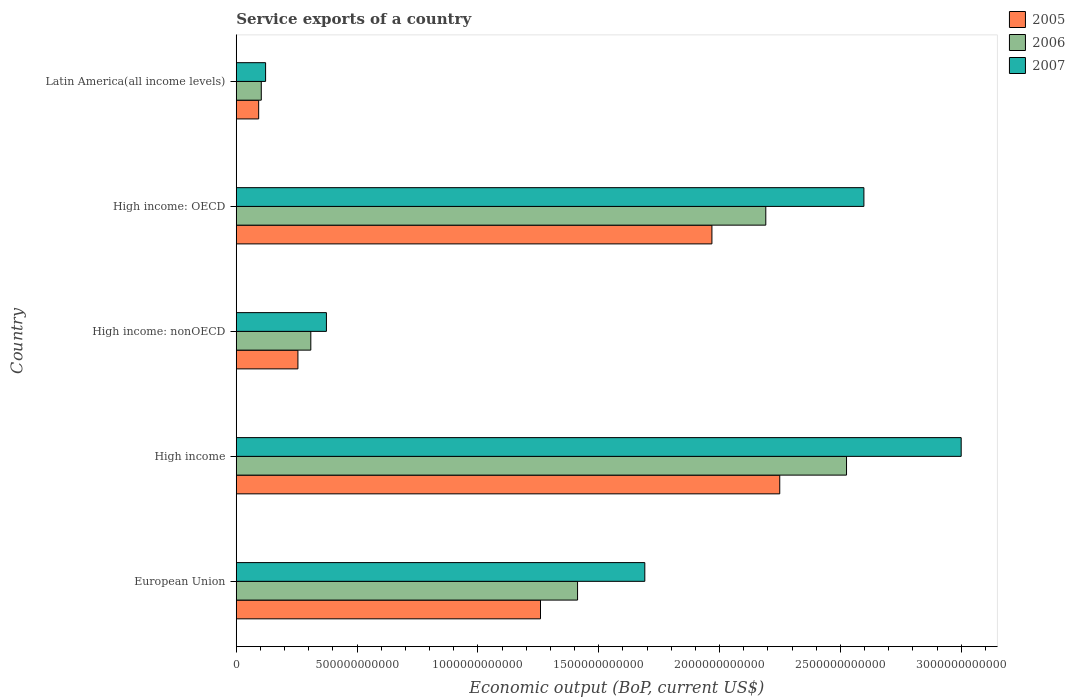How many bars are there on the 1st tick from the bottom?
Offer a very short reply. 3. What is the label of the 1st group of bars from the top?
Your response must be concise. Latin America(all income levels). In how many cases, is the number of bars for a given country not equal to the number of legend labels?
Provide a short and direct response. 0. What is the service exports in 2005 in High income: OECD?
Your answer should be very brief. 1.97e+12. Across all countries, what is the maximum service exports in 2005?
Your answer should be compact. 2.25e+12. Across all countries, what is the minimum service exports in 2006?
Offer a very short reply. 1.04e+11. In which country was the service exports in 2006 maximum?
Your answer should be compact. High income. In which country was the service exports in 2005 minimum?
Offer a terse response. Latin America(all income levels). What is the total service exports in 2006 in the graph?
Provide a short and direct response. 6.54e+12. What is the difference between the service exports in 2007 in High income: OECD and that in High income: nonOECD?
Your answer should be very brief. 2.22e+12. What is the difference between the service exports in 2007 in High income: OECD and the service exports in 2006 in High income?
Keep it short and to the point. 7.19e+1. What is the average service exports in 2005 per country?
Provide a succinct answer. 1.16e+12. What is the difference between the service exports in 2007 and service exports in 2006 in Latin America(all income levels)?
Your answer should be compact. 1.79e+1. In how many countries, is the service exports in 2005 greater than 1800000000000 US$?
Your response must be concise. 2. What is the ratio of the service exports in 2007 in High income: OECD to that in Latin America(all income levels)?
Give a very brief answer. 21.39. Is the difference between the service exports in 2007 in European Union and Latin America(all income levels) greater than the difference between the service exports in 2006 in European Union and Latin America(all income levels)?
Your response must be concise. Yes. What is the difference between the highest and the second highest service exports in 2007?
Provide a succinct answer. 4.03e+11. What is the difference between the highest and the lowest service exports in 2006?
Keep it short and to the point. 2.42e+12. Is it the case that in every country, the sum of the service exports in 2007 and service exports in 2006 is greater than the service exports in 2005?
Offer a terse response. Yes. How many bars are there?
Make the answer very short. 15. Are all the bars in the graph horizontal?
Your response must be concise. Yes. How many countries are there in the graph?
Ensure brevity in your answer.  5. What is the difference between two consecutive major ticks on the X-axis?
Keep it short and to the point. 5.00e+11. Are the values on the major ticks of X-axis written in scientific E-notation?
Offer a terse response. No. Does the graph contain grids?
Your response must be concise. No. How many legend labels are there?
Ensure brevity in your answer.  3. What is the title of the graph?
Make the answer very short. Service exports of a country. What is the label or title of the X-axis?
Offer a terse response. Economic output (BoP, current US$). What is the label or title of the Y-axis?
Offer a terse response. Country. What is the Economic output (BoP, current US$) of 2005 in European Union?
Provide a succinct answer. 1.26e+12. What is the Economic output (BoP, current US$) of 2006 in European Union?
Make the answer very short. 1.41e+12. What is the Economic output (BoP, current US$) in 2007 in European Union?
Make the answer very short. 1.69e+12. What is the Economic output (BoP, current US$) in 2005 in High income?
Provide a short and direct response. 2.25e+12. What is the Economic output (BoP, current US$) in 2006 in High income?
Keep it short and to the point. 2.53e+12. What is the Economic output (BoP, current US$) in 2007 in High income?
Make the answer very short. 3.00e+12. What is the Economic output (BoP, current US$) of 2005 in High income: nonOECD?
Offer a very short reply. 2.55e+11. What is the Economic output (BoP, current US$) of 2006 in High income: nonOECD?
Provide a succinct answer. 3.09e+11. What is the Economic output (BoP, current US$) in 2007 in High income: nonOECD?
Make the answer very short. 3.73e+11. What is the Economic output (BoP, current US$) of 2005 in High income: OECD?
Provide a succinct answer. 1.97e+12. What is the Economic output (BoP, current US$) of 2006 in High income: OECD?
Provide a succinct answer. 2.19e+12. What is the Economic output (BoP, current US$) in 2007 in High income: OECD?
Provide a succinct answer. 2.60e+12. What is the Economic output (BoP, current US$) of 2005 in Latin America(all income levels)?
Offer a terse response. 9.28e+1. What is the Economic output (BoP, current US$) in 2006 in Latin America(all income levels)?
Your answer should be very brief. 1.04e+11. What is the Economic output (BoP, current US$) in 2007 in Latin America(all income levels)?
Make the answer very short. 1.21e+11. Across all countries, what is the maximum Economic output (BoP, current US$) of 2005?
Provide a succinct answer. 2.25e+12. Across all countries, what is the maximum Economic output (BoP, current US$) in 2006?
Make the answer very short. 2.53e+12. Across all countries, what is the maximum Economic output (BoP, current US$) in 2007?
Provide a succinct answer. 3.00e+12. Across all countries, what is the minimum Economic output (BoP, current US$) in 2005?
Your answer should be compact. 9.28e+1. Across all countries, what is the minimum Economic output (BoP, current US$) of 2006?
Offer a terse response. 1.04e+11. Across all countries, what is the minimum Economic output (BoP, current US$) of 2007?
Give a very brief answer. 1.21e+11. What is the total Economic output (BoP, current US$) in 2005 in the graph?
Your response must be concise. 5.82e+12. What is the total Economic output (BoP, current US$) in 2006 in the graph?
Your answer should be compact. 6.54e+12. What is the total Economic output (BoP, current US$) of 2007 in the graph?
Keep it short and to the point. 7.78e+12. What is the difference between the Economic output (BoP, current US$) of 2005 in European Union and that in High income?
Offer a very short reply. -9.90e+11. What is the difference between the Economic output (BoP, current US$) of 2006 in European Union and that in High income?
Offer a very short reply. -1.11e+12. What is the difference between the Economic output (BoP, current US$) in 2007 in European Union and that in High income?
Provide a succinct answer. -1.31e+12. What is the difference between the Economic output (BoP, current US$) in 2005 in European Union and that in High income: nonOECD?
Make the answer very short. 1.00e+12. What is the difference between the Economic output (BoP, current US$) of 2006 in European Union and that in High income: nonOECD?
Your answer should be very brief. 1.10e+12. What is the difference between the Economic output (BoP, current US$) in 2007 in European Union and that in High income: nonOECD?
Offer a very short reply. 1.32e+12. What is the difference between the Economic output (BoP, current US$) in 2005 in European Union and that in High income: OECD?
Make the answer very short. -7.09e+11. What is the difference between the Economic output (BoP, current US$) of 2006 in European Union and that in High income: OECD?
Ensure brevity in your answer.  -7.79e+11. What is the difference between the Economic output (BoP, current US$) in 2007 in European Union and that in High income: OECD?
Your response must be concise. -9.07e+11. What is the difference between the Economic output (BoP, current US$) in 2005 in European Union and that in Latin America(all income levels)?
Your answer should be compact. 1.17e+12. What is the difference between the Economic output (BoP, current US$) in 2006 in European Union and that in Latin America(all income levels)?
Your answer should be compact. 1.31e+12. What is the difference between the Economic output (BoP, current US$) in 2007 in European Union and that in Latin America(all income levels)?
Offer a terse response. 1.57e+12. What is the difference between the Economic output (BoP, current US$) in 2005 in High income and that in High income: nonOECD?
Give a very brief answer. 1.99e+12. What is the difference between the Economic output (BoP, current US$) in 2006 in High income and that in High income: nonOECD?
Your answer should be compact. 2.22e+12. What is the difference between the Economic output (BoP, current US$) in 2007 in High income and that in High income: nonOECD?
Make the answer very short. 2.63e+12. What is the difference between the Economic output (BoP, current US$) of 2005 in High income and that in High income: OECD?
Keep it short and to the point. 2.81e+11. What is the difference between the Economic output (BoP, current US$) in 2006 in High income and that in High income: OECD?
Your answer should be compact. 3.34e+11. What is the difference between the Economic output (BoP, current US$) of 2007 in High income and that in High income: OECD?
Your answer should be compact. 4.03e+11. What is the difference between the Economic output (BoP, current US$) in 2005 in High income and that in Latin America(all income levels)?
Your answer should be compact. 2.16e+12. What is the difference between the Economic output (BoP, current US$) of 2006 in High income and that in Latin America(all income levels)?
Keep it short and to the point. 2.42e+12. What is the difference between the Economic output (BoP, current US$) of 2007 in High income and that in Latin America(all income levels)?
Make the answer very short. 2.88e+12. What is the difference between the Economic output (BoP, current US$) of 2005 in High income: nonOECD and that in High income: OECD?
Your response must be concise. -1.71e+12. What is the difference between the Economic output (BoP, current US$) in 2006 in High income: nonOECD and that in High income: OECD?
Give a very brief answer. -1.88e+12. What is the difference between the Economic output (BoP, current US$) of 2007 in High income: nonOECD and that in High income: OECD?
Your response must be concise. -2.22e+12. What is the difference between the Economic output (BoP, current US$) in 2005 in High income: nonOECD and that in Latin America(all income levels)?
Provide a succinct answer. 1.62e+11. What is the difference between the Economic output (BoP, current US$) of 2006 in High income: nonOECD and that in Latin America(all income levels)?
Your answer should be compact. 2.05e+11. What is the difference between the Economic output (BoP, current US$) in 2007 in High income: nonOECD and that in Latin America(all income levels)?
Your answer should be very brief. 2.52e+11. What is the difference between the Economic output (BoP, current US$) of 2005 in High income: OECD and that in Latin America(all income levels)?
Keep it short and to the point. 1.88e+12. What is the difference between the Economic output (BoP, current US$) of 2006 in High income: OECD and that in Latin America(all income levels)?
Offer a terse response. 2.09e+12. What is the difference between the Economic output (BoP, current US$) in 2007 in High income: OECD and that in Latin America(all income levels)?
Your answer should be very brief. 2.48e+12. What is the difference between the Economic output (BoP, current US$) of 2005 in European Union and the Economic output (BoP, current US$) of 2006 in High income?
Ensure brevity in your answer.  -1.27e+12. What is the difference between the Economic output (BoP, current US$) in 2005 in European Union and the Economic output (BoP, current US$) in 2007 in High income?
Provide a succinct answer. -1.74e+12. What is the difference between the Economic output (BoP, current US$) in 2006 in European Union and the Economic output (BoP, current US$) in 2007 in High income?
Your answer should be very brief. -1.59e+12. What is the difference between the Economic output (BoP, current US$) of 2005 in European Union and the Economic output (BoP, current US$) of 2006 in High income: nonOECD?
Your answer should be very brief. 9.50e+11. What is the difference between the Economic output (BoP, current US$) of 2005 in European Union and the Economic output (BoP, current US$) of 2007 in High income: nonOECD?
Offer a terse response. 8.86e+11. What is the difference between the Economic output (BoP, current US$) of 2006 in European Union and the Economic output (BoP, current US$) of 2007 in High income: nonOECD?
Provide a short and direct response. 1.04e+12. What is the difference between the Economic output (BoP, current US$) of 2005 in European Union and the Economic output (BoP, current US$) of 2006 in High income: OECD?
Offer a very short reply. -9.32e+11. What is the difference between the Economic output (BoP, current US$) in 2005 in European Union and the Economic output (BoP, current US$) in 2007 in High income: OECD?
Provide a succinct answer. -1.34e+12. What is the difference between the Economic output (BoP, current US$) in 2006 in European Union and the Economic output (BoP, current US$) in 2007 in High income: OECD?
Your response must be concise. -1.18e+12. What is the difference between the Economic output (BoP, current US$) of 2005 in European Union and the Economic output (BoP, current US$) of 2006 in Latin America(all income levels)?
Provide a succinct answer. 1.16e+12. What is the difference between the Economic output (BoP, current US$) in 2005 in European Union and the Economic output (BoP, current US$) in 2007 in Latin America(all income levels)?
Offer a very short reply. 1.14e+12. What is the difference between the Economic output (BoP, current US$) of 2006 in European Union and the Economic output (BoP, current US$) of 2007 in Latin America(all income levels)?
Your answer should be compact. 1.29e+12. What is the difference between the Economic output (BoP, current US$) of 2005 in High income and the Economic output (BoP, current US$) of 2006 in High income: nonOECD?
Provide a succinct answer. 1.94e+12. What is the difference between the Economic output (BoP, current US$) of 2005 in High income and the Economic output (BoP, current US$) of 2007 in High income: nonOECD?
Your answer should be very brief. 1.88e+12. What is the difference between the Economic output (BoP, current US$) in 2006 in High income and the Economic output (BoP, current US$) in 2007 in High income: nonOECD?
Offer a very short reply. 2.15e+12. What is the difference between the Economic output (BoP, current US$) in 2005 in High income and the Economic output (BoP, current US$) in 2006 in High income: OECD?
Offer a terse response. 5.77e+1. What is the difference between the Economic output (BoP, current US$) of 2005 in High income and the Economic output (BoP, current US$) of 2007 in High income: OECD?
Your answer should be compact. -3.48e+11. What is the difference between the Economic output (BoP, current US$) of 2006 in High income and the Economic output (BoP, current US$) of 2007 in High income: OECD?
Your response must be concise. -7.19e+1. What is the difference between the Economic output (BoP, current US$) in 2005 in High income and the Economic output (BoP, current US$) in 2006 in Latin America(all income levels)?
Provide a succinct answer. 2.15e+12. What is the difference between the Economic output (BoP, current US$) in 2005 in High income and the Economic output (BoP, current US$) in 2007 in Latin America(all income levels)?
Your answer should be very brief. 2.13e+12. What is the difference between the Economic output (BoP, current US$) in 2006 in High income and the Economic output (BoP, current US$) in 2007 in Latin America(all income levels)?
Offer a very short reply. 2.40e+12. What is the difference between the Economic output (BoP, current US$) of 2005 in High income: nonOECD and the Economic output (BoP, current US$) of 2006 in High income: OECD?
Your answer should be compact. -1.94e+12. What is the difference between the Economic output (BoP, current US$) of 2005 in High income: nonOECD and the Economic output (BoP, current US$) of 2007 in High income: OECD?
Offer a very short reply. -2.34e+12. What is the difference between the Economic output (BoP, current US$) in 2006 in High income: nonOECD and the Economic output (BoP, current US$) in 2007 in High income: OECD?
Ensure brevity in your answer.  -2.29e+12. What is the difference between the Economic output (BoP, current US$) in 2005 in High income: nonOECD and the Economic output (BoP, current US$) in 2006 in Latin America(all income levels)?
Provide a short and direct response. 1.52e+11. What is the difference between the Economic output (BoP, current US$) of 2005 in High income: nonOECD and the Economic output (BoP, current US$) of 2007 in Latin America(all income levels)?
Offer a terse response. 1.34e+11. What is the difference between the Economic output (BoP, current US$) of 2006 in High income: nonOECD and the Economic output (BoP, current US$) of 2007 in Latin America(all income levels)?
Offer a very short reply. 1.87e+11. What is the difference between the Economic output (BoP, current US$) of 2005 in High income: OECD and the Economic output (BoP, current US$) of 2006 in Latin America(all income levels)?
Make the answer very short. 1.86e+12. What is the difference between the Economic output (BoP, current US$) in 2005 in High income: OECD and the Economic output (BoP, current US$) in 2007 in Latin America(all income levels)?
Make the answer very short. 1.85e+12. What is the difference between the Economic output (BoP, current US$) in 2006 in High income: OECD and the Economic output (BoP, current US$) in 2007 in Latin America(all income levels)?
Offer a very short reply. 2.07e+12. What is the average Economic output (BoP, current US$) in 2005 per country?
Your answer should be very brief. 1.16e+12. What is the average Economic output (BoP, current US$) in 2006 per country?
Provide a short and direct response. 1.31e+12. What is the average Economic output (BoP, current US$) in 2007 per country?
Offer a terse response. 1.56e+12. What is the difference between the Economic output (BoP, current US$) in 2005 and Economic output (BoP, current US$) in 2006 in European Union?
Make the answer very short. -1.53e+11. What is the difference between the Economic output (BoP, current US$) of 2005 and Economic output (BoP, current US$) of 2007 in European Union?
Make the answer very short. -4.32e+11. What is the difference between the Economic output (BoP, current US$) in 2006 and Economic output (BoP, current US$) in 2007 in European Union?
Offer a very short reply. -2.78e+11. What is the difference between the Economic output (BoP, current US$) in 2005 and Economic output (BoP, current US$) in 2006 in High income?
Ensure brevity in your answer.  -2.76e+11. What is the difference between the Economic output (BoP, current US$) of 2005 and Economic output (BoP, current US$) of 2007 in High income?
Offer a terse response. -7.51e+11. What is the difference between the Economic output (BoP, current US$) in 2006 and Economic output (BoP, current US$) in 2007 in High income?
Offer a very short reply. -4.74e+11. What is the difference between the Economic output (BoP, current US$) of 2005 and Economic output (BoP, current US$) of 2006 in High income: nonOECD?
Your response must be concise. -5.33e+1. What is the difference between the Economic output (BoP, current US$) of 2005 and Economic output (BoP, current US$) of 2007 in High income: nonOECD?
Give a very brief answer. -1.18e+11. What is the difference between the Economic output (BoP, current US$) in 2006 and Economic output (BoP, current US$) in 2007 in High income: nonOECD?
Keep it short and to the point. -6.46e+1. What is the difference between the Economic output (BoP, current US$) of 2005 and Economic output (BoP, current US$) of 2006 in High income: OECD?
Offer a terse response. -2.23e+11. What is the difference between the Economic output (BoP, current US$) of 2005 and Economic output (BoP, current US$) of 2007 in High income: OECD?
Provide a succinct answer. -6.29e+11. What is the difference between the Economic output (BoP, current US$) of 2006 and Economic output (BoP, current US$) of 2007 in High income: OECD?
Keep it short and to the point. -4.06e+11. What is the difference between the Economic output (BoP, current US$) in 2005 and Economic output (BoP, current US$) in 2006 in Latin America(all income levels)?
Ensure brevity in your answer.  -1.08e+1. What is the difference between the Economic output (BoP, current US$) in 2005 and Economic output (BoP, current US$) in 2007 in Latin America(all income levels)?
Provide a short and direct response. -2.87e+1. What is the difference between the Economic output (BoP, current US$) of 2006 and Economic output (BoP, current US$) of 2007 in Latin America(all income levels)?
Your response must be concise. -1.79e+1. What is the ratio of the Economic output (BoP, current US$) of 2005 in European Union to that in High income?
Provide a succinct answer. 0.56. What is the ratio of the Economic output (BoP, current US$) in 2006 in European Union to that in High income?
Provide a succinct answer. 0.56. What is the ratio of the Economic output (BoP, current US$) in 2007 in European Union to that in High income?
Keep it short and to the point. 0.56. What is the ratio of the Economic output (BoP, current US$) of 2005 in European Union to that in High income: nonOECD?
Provide a short and direct response. 4.93. What is the ratio of the Economic output (BoP, current US$) in 2006 in European Union to that in High income: nonOECD?
Ensure brevity in your answer.  4.58. What is the ratio of the Economic output (BoP, current US$) of 2007 in European Union to that in High income: nonOECD?
Make the answer very short. 4.53. What is the ratio of the Economic output (BoP, current US$) in 2005 in European Union to that in High income: OECD?
Provide a short and direct response. 0.64. What is the ratio of the Economic output (BoP, current US$) in 2006 in European Union to that in High income: OECD?
Your response must be concise. 0.64. What is the ratio of the Economic output (BoP, current US$) of 2007 in European Union to that in High income: OECD?
Your response must be concise. 0.65. What is the ratio of the Economic output (BoP, current US$) in 2005 in European Union to that in Latin America(all income levels)?
Provide a succinct answer. 13.57. What is the ratio of the Economic output (BoP, current US$) in 2006 in European Union to that in Latin America(all income levels)?
Provide a succinct answer. 13.64. What is the ratio of the Economic output (BoP, current US$) in 2007 in European Union to that in Latin America(all income levels)?
Provide a succinct answer. 13.92. What is the ratio of the Economic output (BoP, current US$) of 2005 in High income to that in High income: nonOECD?
Provide a succinct answer. 8.81. What is the ratio of the Economic output (BoP, current US$) in 2006 in High income to that in High income: nonOECD?
Your answer should be very brief. 8.19. What is the ratio of the Economic output (BoP, current US$) in 2007 in High income to that in High income: nonOECD?
Make the answer very short. 8.04. What is the ratio of the Economic output (BoP, current US$) of 2005 in High income to that in High income: OECD?
Provide a short and direct response. 1.14. What is the ratio of the Economic output (BoP, current US$) in 2006 in High income to that in High income: OECD?
Provide a short and direct response. 1.15. What is the ratio of the Economic output (BoP, current US$) in 2007 in High income to that in High income: OECD?
Give a very brief answer. 1.16. What is the ratio of the Economic output (BoP, current US$) in 2005 in High income to that in Latin America(all income levels)?
Keep it short and to the point. 24.24. What is the ratio of the Economic output (BoP, current US$) in 2006 in High income to that in Latin America(all income levels)?
Provide a short and direct response. 24.39. What is the ratio of the Economic output (BoP, current US$) in 2007 in High income to that in Latin America(all income levels)?
Your answer should be compact. 24.7. What is the ratio of the Economic output (BoP, current US$) of 2005 in High income: nonOECD to that in High income: OECD?
Ensure brevity in your answer.  0.13. What is the ratio of the Economic output (BoP, current US$) of 2006 in High income: nonOECD to that in High income: OECD?
Keep it short and to the point. 0.14. What is the ratio of the Economic output (BoP, current US$) of 2007 in High income: nonOECD to that in High income: OECD?
Keep it short and to the point. 0.14. What is the ratio of the Economic output (BoP, current US$) of 2005 in High income: nonOECD to that in Latin America(all income levels)?
Give a very brief answer. 2.75. What is the ratio of the Economic output (BoP, current US$) of 2006 in High income: nonOECD to that in Latin America(all income levels)?
Provide a short and direct response. 2.98. What is the ratio of the Economic output (BoP, current US$) of 2007 in High income: nonOECD to that in Latin America(all income levels)?
Your answer should be very brief. 3.07. What is the ratio of the Economic output (BoP, current US$) of 2005 in High income: OECD to that in Latin America(all income levels)?
Keep it short and to the point. 21.22. What is the ratio of the Economic output (BoP, current US$) of 2006 in High income: OECD to that in Latin America(all income levels)?
Make the answer very short. 21.16. What is the ratio of the Economic output (BoP, current US$) of 2007 in High income: OECD to that in Latin America(all income levels)?
Your answer should be compact. 21.39. What is the difference between the highest and the second highest Economic output (BoP, current US$) of 2005?
Your response must be concise. 2.81e+11. What is the difference between the highest and the second highest Economic output (BoP, current US$) in 2006?
Make the answer very short. 3.34e+11. What is the difference between the highest and the second highest Economic output (BoP, current US$) in 2007?
Ensure brevity in your answer.  4.03e+11. What is the difference between the highest and the lowest Economic output (BoP, current US$) in 2005?
Your answer should be very brief. 2.16e+12. What is the difference between the highest and the lowest Economic output (BoP, current US$) in 2006?
Your response must be concise. 2.42e+12. What is the difference between the highest and the lowest Economic output (BoP, current US$) of 2007?
Offer a terse response. 2.88e+12. 